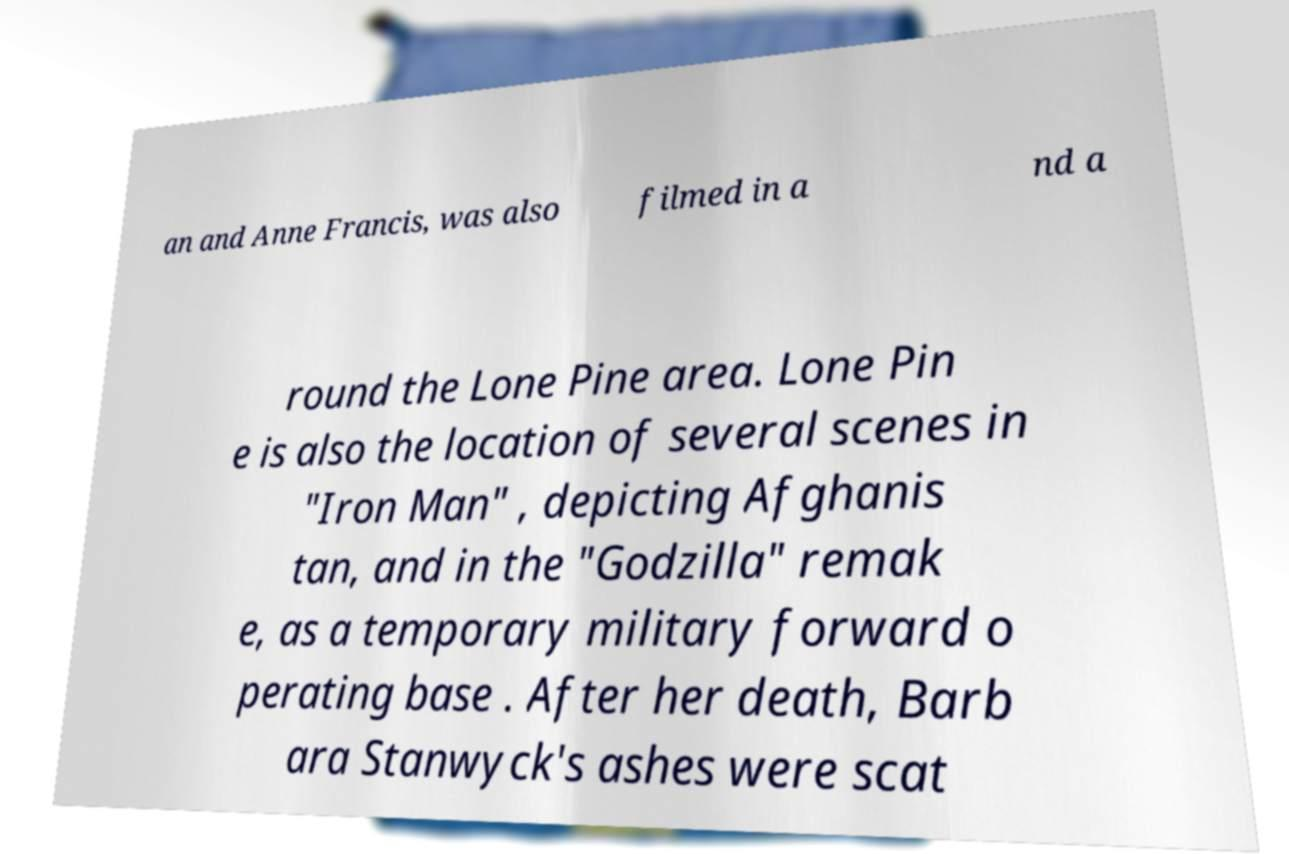Can you accurately transcribe the text from the provided image for me? an and Anne Francis, was also filmed in a nd a round the Lone Pine area. Lone Pin e is also the location of several scenes in "Iron Man" , depicting Afghanis tan, and in the "Godzilla" remak e, as a temporary military forward o perating base . After her death, Barb ara Stanwyck's ashes were scat 